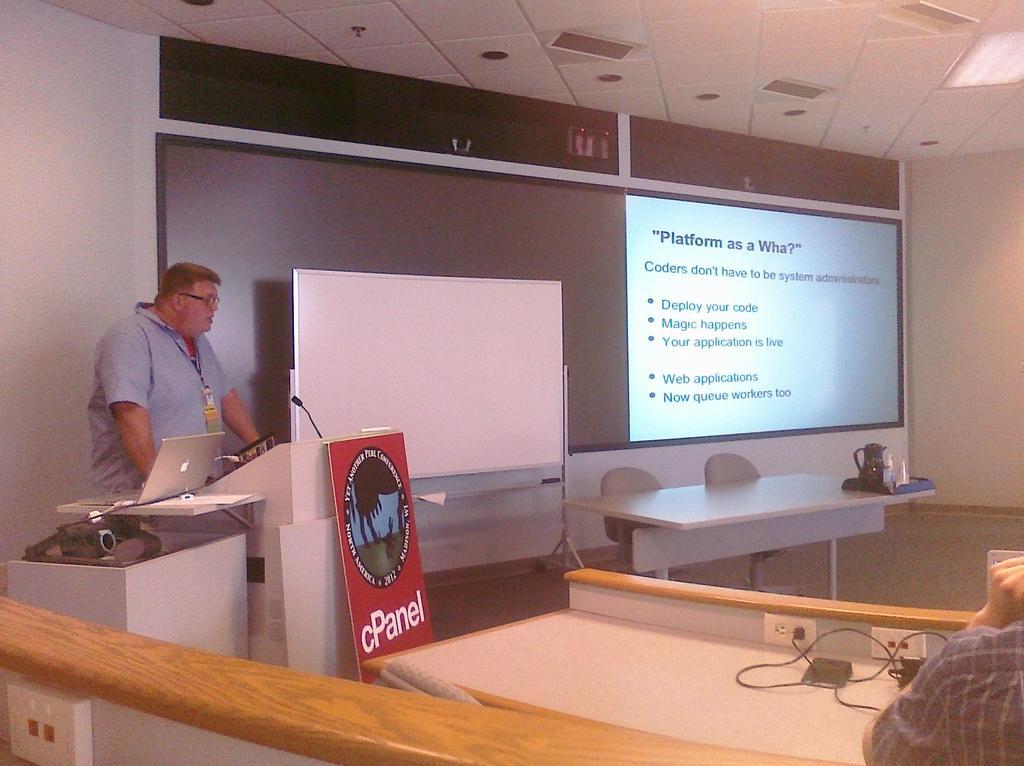Please provide a concise description of this image. A picture of a conference room. This is a screen. A whiteboard. A podium with mic and poster. On a table there is laptop. A man is standing back side of this podium. Chairs and tables. On this table there is a tray, jar and cups. Person is sitting on a chair, in-front of him there is a table, on a table there is a cables and socket. 